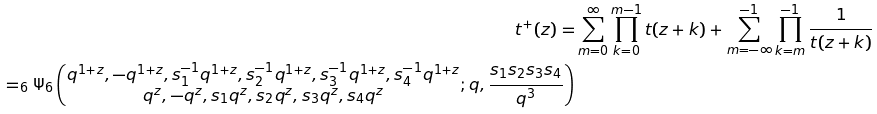<formula> <loc_0><loc_0><loc_500><loc_500>t ^ { + } ( z ) = & \sum _ { m = 0 } ^ { \infty } \prod _ { k = 0 } ^ { m - 1 } t ( z + k ) + \sum _ { m = - \infty } ^ { - 1 } \prod _ { k = m } ^ { - 1 } \frac { 1 } { t ( z + k ) } \\ = _ { 6 } \Psi _ { 6 } \left ( \begin{matrix} q ^ { 1 + z } , - q ^ { 1 + z } , s _ { 1 } ^ { - 1 } q ^ { 1 + z } , s _ { 2 } ^ { - 1 } q ^ { 1 + z } , s _ { 3 } ^ { - 1 } q ^ { 1 + z } , s _ { 4 } ^ { - 1 } q ^ { 1 + z } \\ q ^ { z } , - q ^ { z } , s _ { 1 } q ^ { z } , s _ { 2 } q ^ { z } , s _ { 3 } q ^ { z } , s _ { 4 } q ^ { z } \end{matrix} ; q , \frac { s _ { 1 } s _ { 2 } s _ { 3 } s _ { 4 } } { q ^ { 3 } } \right )</formula> 